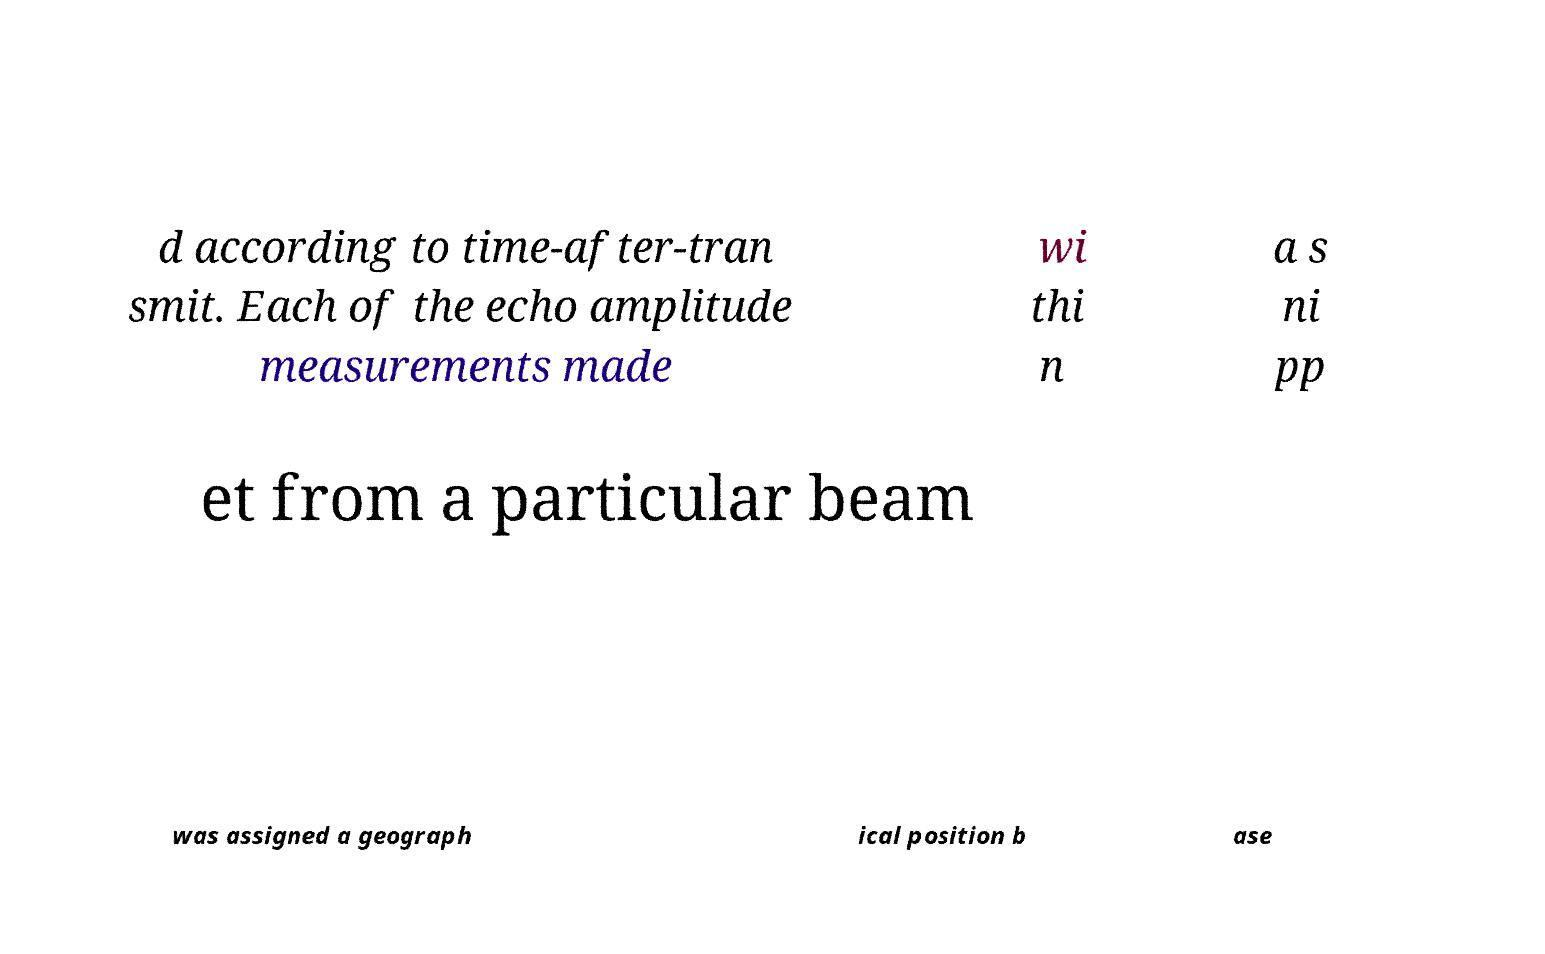There's text embedded in this image that I need extracted. Can you transcribe it verbatim? d according to time-after-tran smit. Each of the echo amplitude measurements made wi thi n a s ni pp et from a particular beam was assigned a geograph ical position b ase 